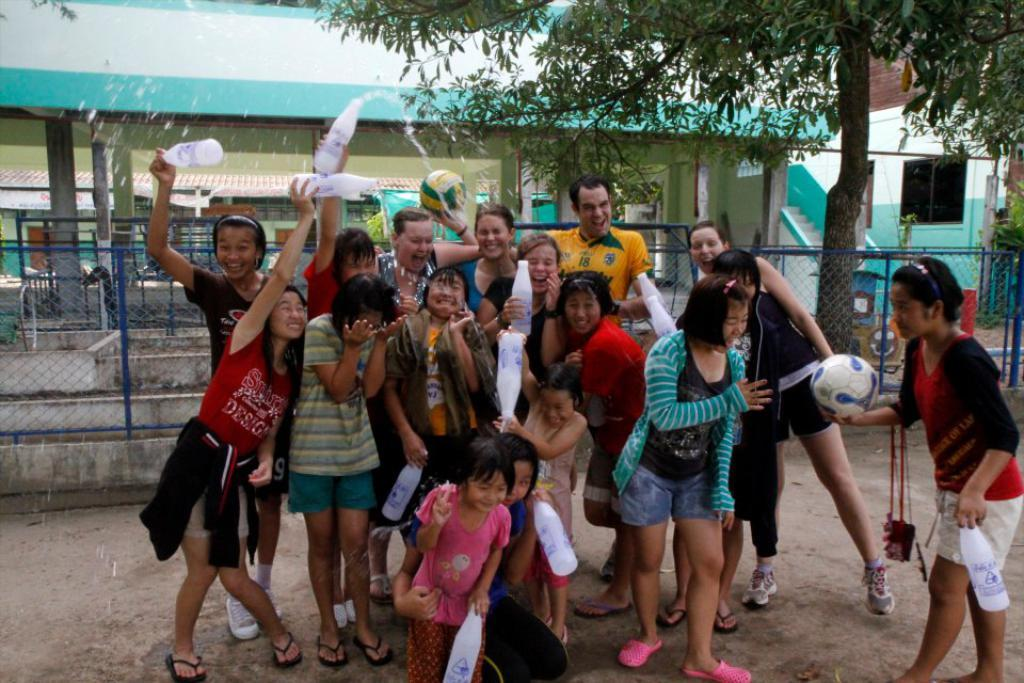What type of natural element is present in the image? There is a tree in the image. What type of structure can be seen in the image? There is a building in the image. What type of barrier is present in the image? There is a fence in the image. Are there any human figures in the image? Yes, there are people standing in the image. What type of sheet is being used by the people in the image? There is no sheet present in the image; it features a tree, a fence, a building, and people standing. Can you tell me the name of the aunt who is standing in the image? There is no aunt mentioned or depicted in the image. 